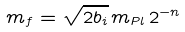Convert formula to latex. <formula><loc_0><loc_0><loc_500><loc_500>m _ { f } = \sqrt { 2 b _ { i } } \, m _ { P l } \, 2 ^ { - n }</formula> 